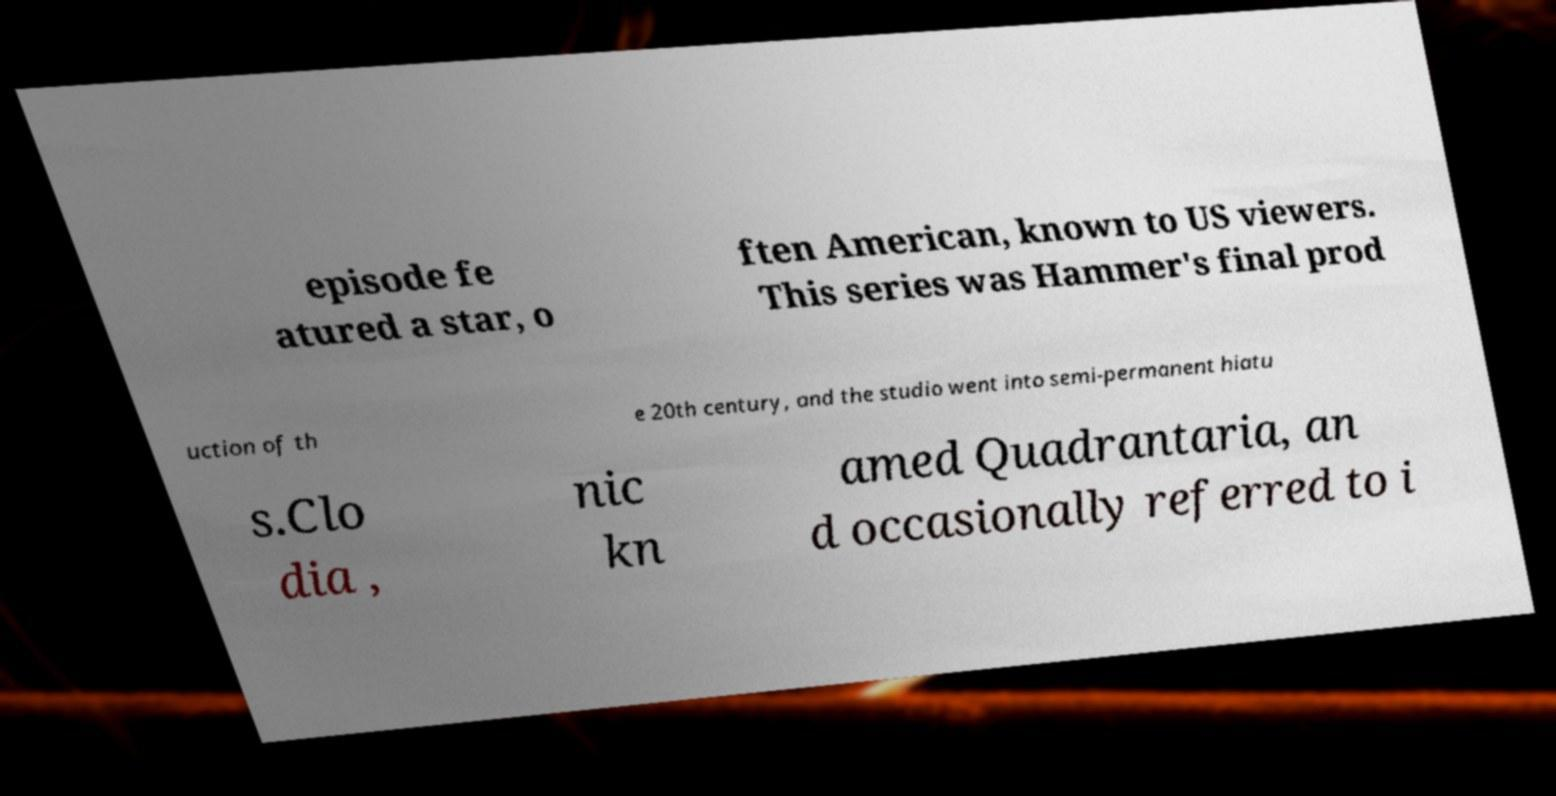For documentation purposes, I need the text within this image transcribed. Could you provide that? episode fe atured a star, o ften American, known to US viewers. This series was Hammer's final prod uction of th e 20th century, and the studio went into semi-permanent hiatu s.Clo dia , nic kn amed Quadrantaria, an d occasionally referred to i 